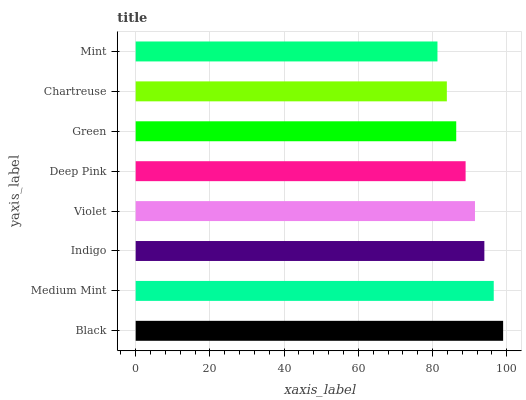Is Mint the minimum?
Answer yes or no. Yes. Is Black the maximum?
Answer yes or no. Yes. Is Medium Mint the minimum?
Answer yes or no. No. Is Medium Mint the maximum?
Answer yes or no. No. Is Black greater than Medium Mint?
Answer yes or no. Yes. Is Medium Mint less than Black?
Answer yes or no. Yes. Is Medium Mint greater than Black?
Answer yes or no. No. Is Black less than Medium Mint?
Answer yes or no. No. Is Violet the high median?
Answer yes or no. Yes. Is Deep Pink the low median?
Answer yes or no. Yes. Is Black the high median?
Answer yes or no. No. Is Indigo the low median?
Answer yes or no. No. 